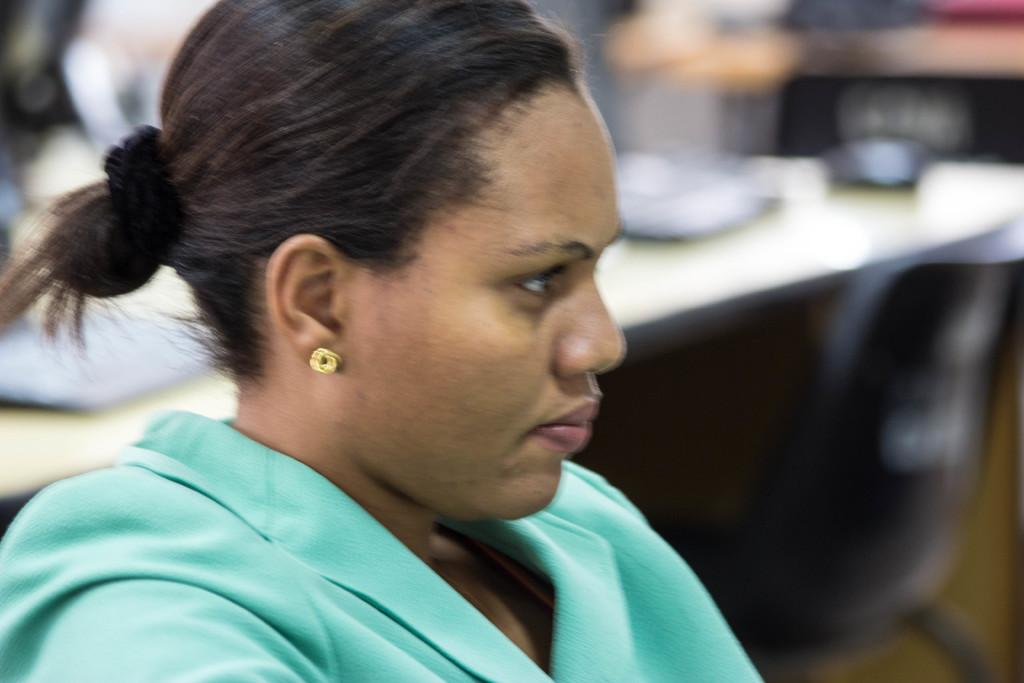Who is the main subject in the image? There is a lady in the image. What is the lady doing in the image? The lady is sitting on a chair. Can you describe the background of the image? The background of the image is blurred. What type of bridge can be seen in the background of the image? There is no bridge visible in the background of the image; it is blurred. 